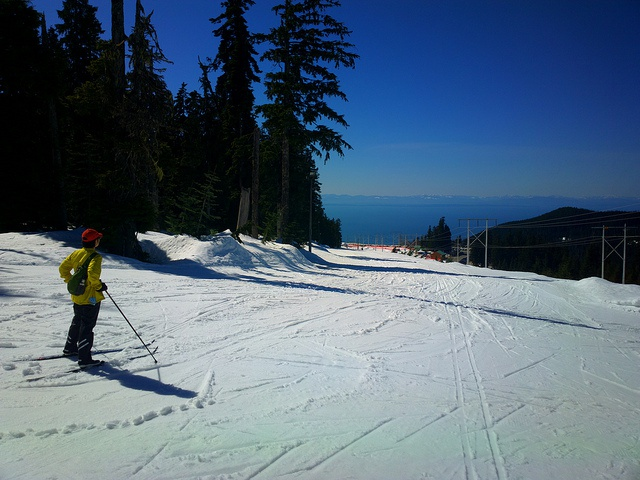Describe the objects in this image and their specific colors. I can see people in black, olive, darkgray, and maroon tones, skis in black, darkgray, gray, and navy tones, and backpack in black, darkgreen, and gray tones in this image. 